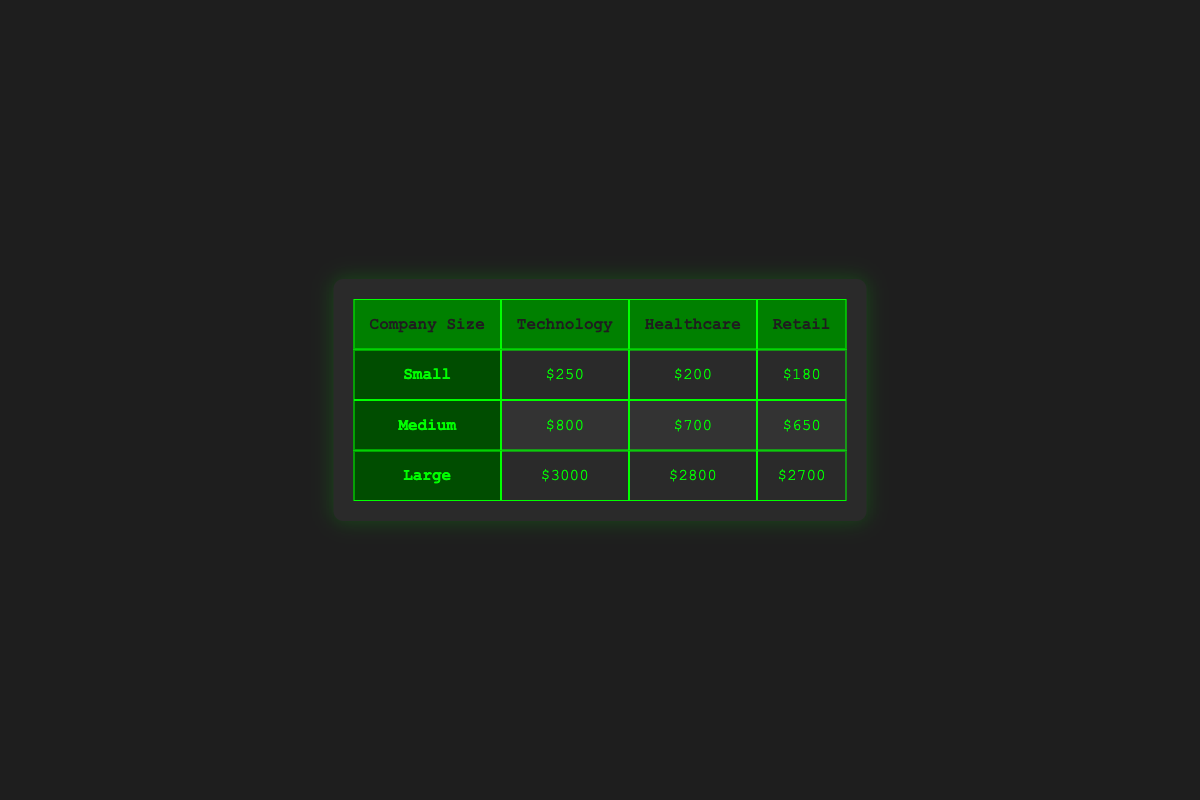What is the monthly cost for a small healthcare company? The table indicates that the monthly cost for a small company in the healthcare industry is $200.
Answer: $200 Which industry has the highest monthly cost for large companies? The table shows that the large company in the technology industry has a monthly cost of $3000, which is higher than the fees for healthcare ($2800) and retail ($2700).
Answer: Technology What is the difference in monthly cost between medium and large healthcare companies? For medium healthcare companies, the cost is $700, while for large healthcare companies, the cost is $2800. The difference is $2800 - $700 = $2100.
Answer: $2100 Do small retail companies have a higher monthly cost than small technology companies? The monthly cost for small retail companies is $180, while for small technology companies it is $250, indicating that small retail companies do not have higher costs.
Answer: No What is the average monthly cost for all small companies across industries? The monthly costs for small companies are $250 (technology), $200 (healthcare), and $180 (retail). The sum of these costs is $250 + $200 + $180 = $630, and dividing this sum by 3 gives an average of $630 / 3 = $210.
Answer: $210 Which company size incurs the least monthly cost in the retail industry? The table shows monthly costs for small ($180), medium ($650), and large ($2700) retail companies. Among these, small retail companies have the lowest cost of $180.
Answer: Small Is there a notable pattern in costs between different company sizes in the technology industry? Yes, the table illustrates an upward pattern in costs from small ($250) to medium ($800) to large ($3000) technology companies, indicating that larger companies typically incur higher costs.
Answer: Yes What is the total monthly cost for all medium-sized companies across industries? The monthly costs for medium-sized companies are $800 (technology), $700 (healthcare), and $650 (retail). The total is calculated by adding these amounts: $800 + $700 + $650 = $2150.
Answer: $2150 